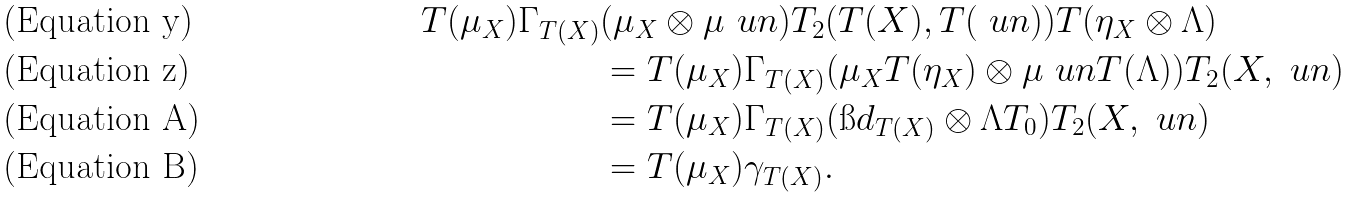<formula> <loc_0><loc_0><loc_500><loc_500>T ( \mu _ { X } ) \Gamma _ { T ( X ) } & ( \mu _ { X } \otimes \mu _ { \ } u n ) T _ { 2 } ( T ( X ) , T ( \ u n ) ) T ( \eta _ { X } \otimes \Lambda ) \\ & = T ( \mu _ { X } ) \Gamma _ { T ( X ) } ( \mu _ { X } T ( \eta _ { X } ) \otimes \mu _ { \ } u n T ( \Lambda ) ) T _ { 2 } ( X , \ u n ) \\ & = T ( \mu _ { X } ) \Gamma _ { T ( X ) } ( \i d _ { T ( X ) } \otimes \Lambda T _ { 0 } ) T _ { 2 } ( X , \ u n ) \\ & = T ( \mu _ { X } ) \gamma _ { T ( X ) } .</formula> 